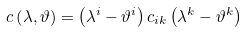<formula> <loc_0><loc_0><loc_500><loc_500>c \left ( \lambda , \vartheta \right ) = \left ( \lambda ^ { i } - \vartheta ^ { i } \right ) c _ { i k } \left ( \lambda ^ { k } - \vartheta ^ { k } \right )</formula> 